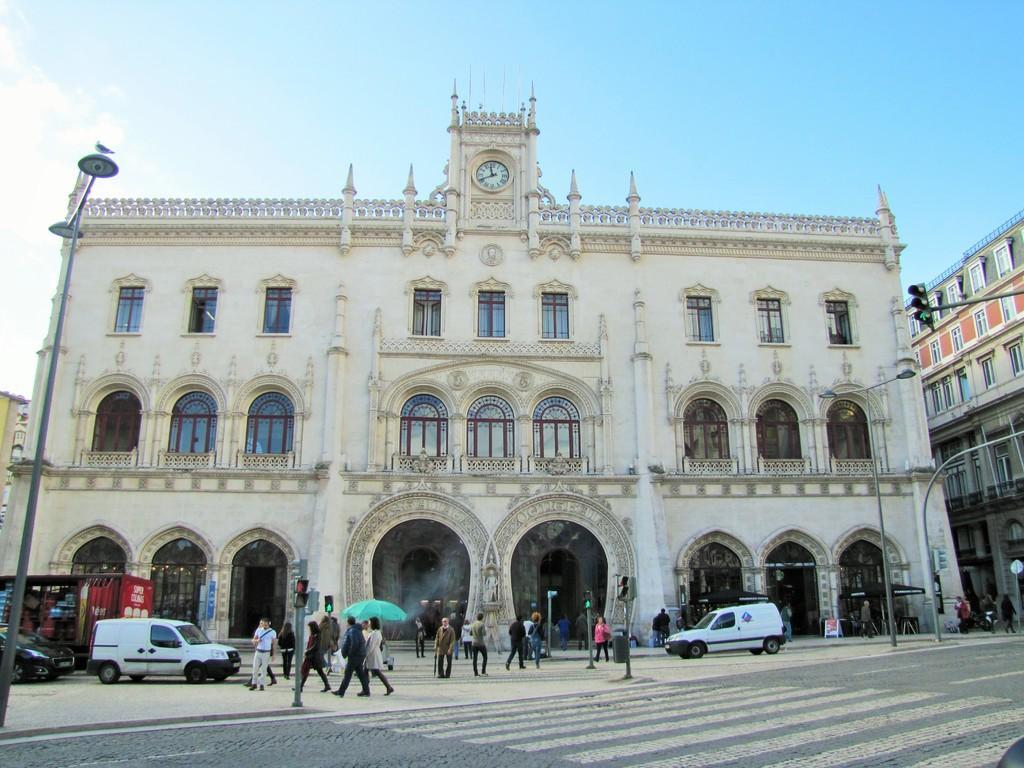Please provide a concise description of this image. In this image there are group of people walking on the street , there are signal lights and lights attached to the poles, buildings, vehicles , and in the background there is sky. 